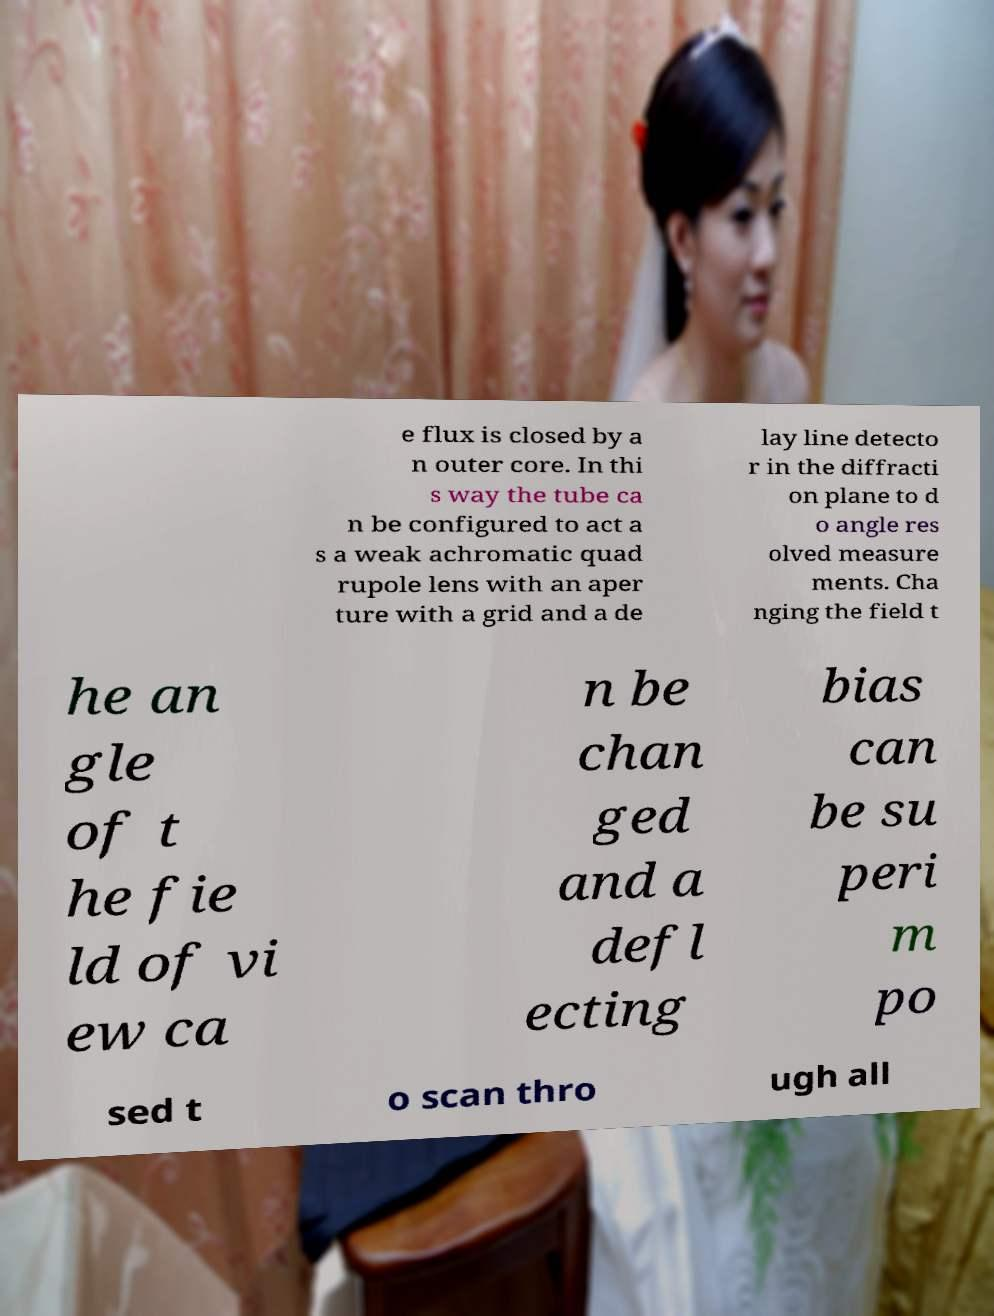Please identify and transcribe the text found in this image. e flux is closed by a n outer core. In thi s way the tube ca n be configured to act a s a weak achromatic quad rupole lens with an aper ture with a grid and a de lay line detecto r in the diffracti on plane to d o angle res olved measure ments. Cha nging the field t he an gle of t he fie ld of vi ew ca n be chan ged and a defl ecting bias can be su peri m po sed t o scan thro ugh all 